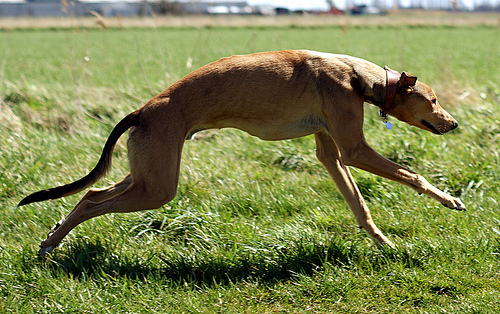<image>
Is the dog above the grass? Yes. The dog is positioned above the grass in the vertical space, higher up in the scene. 